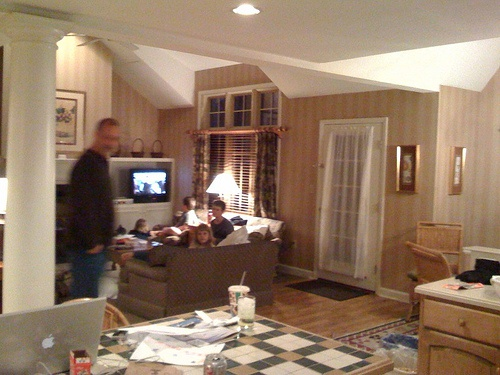Describe the objects in this image and their specific colors. I can see dining table in olive, ivory, tan, and gray tones, couch in olive, maroon, black, and gray tones, laptop in olive, gray, and darkgray tones, people in olive, black, maroon, and brown tones, and chair in olive, brown, gray, and maroon tones in this image. 